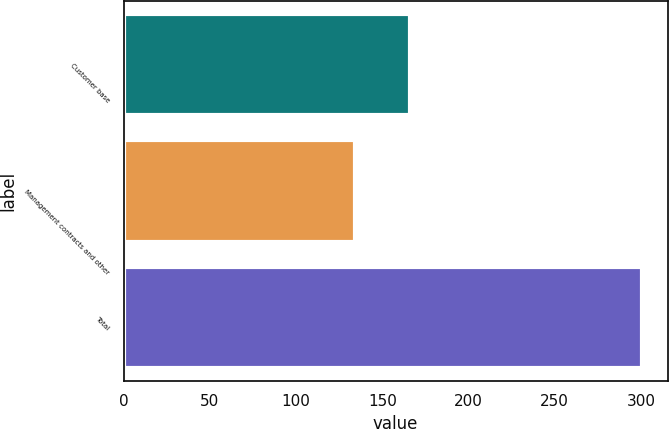Convert chart. <chart><loc_0><loc_0><loc_500><loc_500><bar_chart><fcel>Customer base<fcel>Management contracts and other<fcel>Total<nl><fcel>166.2<fcel>134.2<fcel>300.4<nl></chart> 